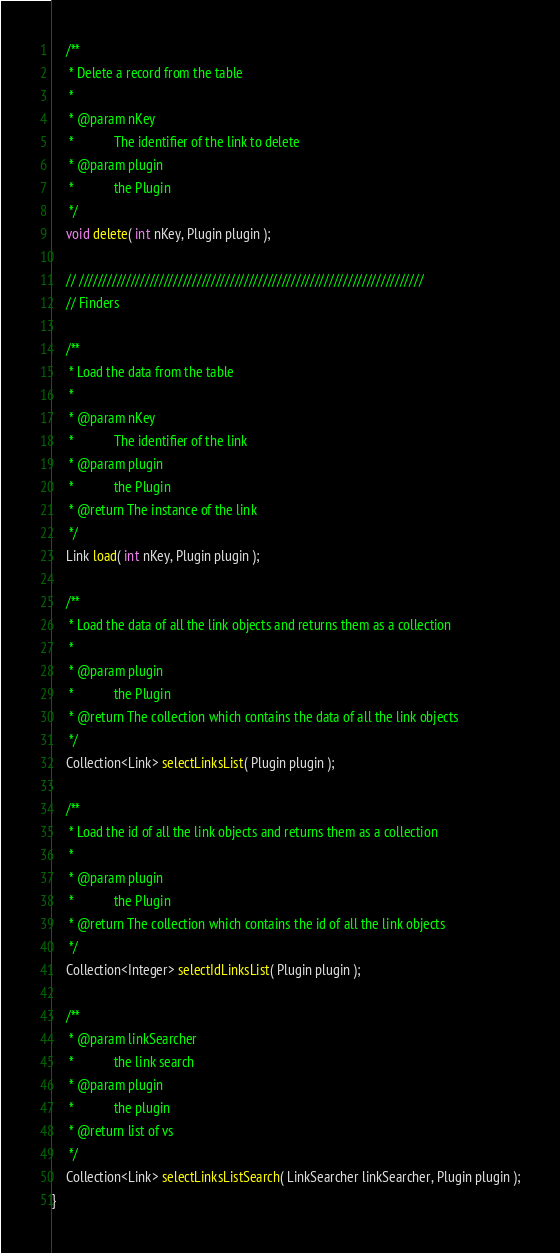Convert code to text. <code><loc_0><loc_0><loc_500><loc_500><_Java_>
    /**
     * Delete a record from the table
     * 
     * @param nKey
     *            The identifier of the link to delete
     * @param plugin
     *            the Plugin
     */
    void delete( int nKey, Plugin plugin );

    // /////////////////////////////////////////////////////////////////////////
    // Finders

    /**
     * Load the data from the table
     * 
     * @param nKey
     *            The identifier of the link
     * @param plugin
     *            the Plugin
     * @return The instance of the link
     */
    Link load( int nKey, Plugin plugin );

    /**
     * Load the data of all the link objects and returns them as a collection
     * 
     * @param plugin
     *            the Plugin
     * @return The collection which contains the data of all the link objects
     */
    Collection<Link> selectLinksList( Plugin plugin );

    /**
     * Load the id of all the link objects and returns them as a collection
     * 
     * @param plugin
     *            the Plugin
     * @return The collection which contains the id of all the link objects
     */
    Collection<Integer> selectIdLinksList( Plugin plugin );

    /**
     * @param linkSearcher
     *            the link search
     * @param plugin
     *            the plugin
     * @return list of vs
     */
    Collection<Link> selectLinksListSearch( LinkSearcher linkSearcher, Plugin plugin );
}
</code> 